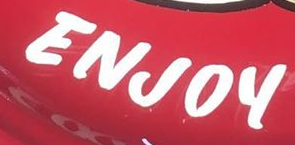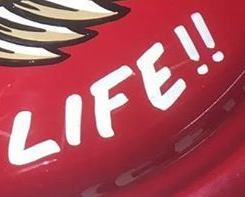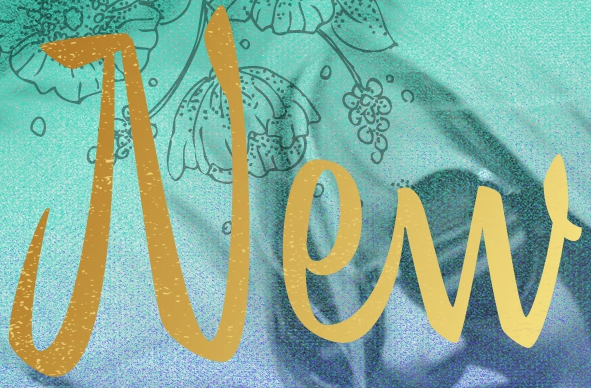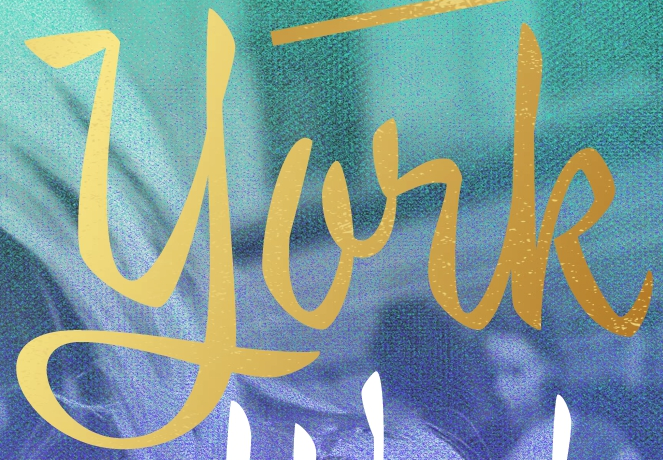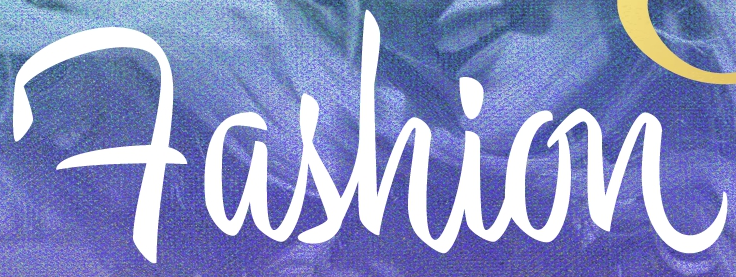Read the text content from these images in order, separated by a semicolon. ENJOY; LIFE!!; New; york; Fashion 